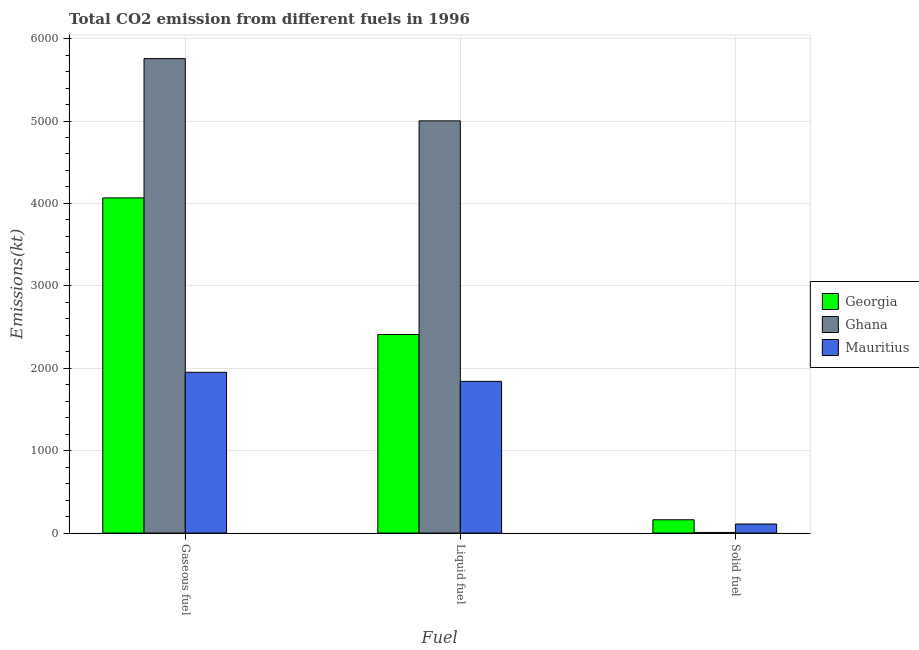How many groups of bars are there?
Give a very brief answer. 3. How many bars are there on the 3rd tick from the left?
Keep it short and to the point. 3. What is the label of the 3rd group of bars from the left?
Give a very brief answer. Solid fuel. What is the amount of co2 emissions from gaseous fuel in Mauritius?
Offer a terse response. 1950.84. Across all countries, what is the maximum amount of co2 emissions from solid fuel?
Offer a terse response. 161.35. Across all countries, what is the minimum amount of co2 emissions from solid fuel?
Give a very brief answer. 7.33. In which country was the amount of co2 emissions from gaseous fuel maximum?
Make the answer very short. Ghana. In which country was the amount of co2 emissions from liquid fuel minimum?
Give a very brief answer. Mauritius. What is the total amount of co2 emissions from gaseous fuel in the graph?
Ensure brevity in your answer.  1.18e+04. What is the difference between the amount of co2 emissions from liquid fuel in Georgia and that in Ghana?
Keep it short and to the point. -2592.57. What is the difference between the amount of co2 emissions from solid fuel in Georgia and the amount of co2 emissions from gaseous fuel in Mauritius?
Provide a succinct answer. -1789.5. What is the average amount of co2 emissions from liquid fuel per country?
Make the answer very short. 3083.95. What is the difference between the amount of co2 emissions from gaseous fuel and amount of co2 emissions from liquid fuel in Ghana?
Make the answer very short. 755.4. In how many countries, is the amount of co2 emissions from liquid fuel greater than 3800 kt?
Ensure brevity in your answer.  1. What is the ratio of the amount of co2 emissions from gaseous fuel in Ghana to that in Georgia?
Provide a succinct answer. 1.42. Is the amount of co2 emissions from solid fuel in Ghana less than that in Mauritius?
Make the answer very short. Yes. What is the difference between the highest and the second highest amount of co2 emissions from gaseous fuel?
Your response must be concise. 1690.49. What is the difference between the highest and the lowest amount of co2 emissions from gaseous fuel?
Keep it short and to the point. 3806.35. Is the sum of the amount of co2 emissions from liquid fuel in Georgia and Mauritius greater than the maximum amount of co2 emissions from gaseous fuel across all countries?
Offer a terse response. No. What does the 1st bar from the left in Liquid fuel represents?
Give a very brief answer. Georgia. What does the 3rd bar from the right in Liquid fuel represents?
Provide a succinct answer. Georgia. How many countries are there in the graph?
Keep it short and to the point. 3. Does the graph contain any zero values?
Provide a succinct answer. No. Does the graph contain grids?
Keep it short and to the point. Yes. How many legend labels are there?
Your response must be concise. 3. How are the legend labels stacked?
Your answer should be very brief. Vertical. What is the title of the graph?
Offer a very short reply. Total CO2 emission from different fuels in 1996. What is the label or title of the X-axis?
Provide a short and direct response. Fuel. What is the label or title of the Y-axis?
Provide a succinct answer. Emissions(kt). What is the Emissions(kt) in Georgia in Gaseous fuel?
Ensure brevity in your answer.  4066.7. What is the Emissions(kt) in Ghana in Gaseous fuel?
Your answer should be compact. 5757.19. What is the Emissions(kt) of Mauritius in Gaseous fuel?
Offer a terse response. 1950.84. What is the Emissions(kt) of Georgia in Liquid fuel?
Offer a very short reply. 2409.22. What is the Emissions(kt) of Ghana in Liquid fuel?
Ensure brevity in your answer.  5001.79. What is the Emissions(kt) of Mauritius in Liquid fuel?
Provide a short and direct response. 1840.83. What is the Emissions(kt) in Georgia in Solid fuel?
Offer a terse response. 161.35. What is the Emissions(kt) in Ghana in Solid fuel?
Your answer should be compact. 7.33. What is the Emissions(kt) in Mauritius in Solid fuel?
Ensure brevity in your answer.  110.01. Across all Fuel, what is the maximum Emissions(kt) of Georgia?
Your answer should be compact. 4066.7. Across all Fuel, what is the maximum Emissions(kt) in Ghana?
Make the answer very short. 5757.19. Across all Fuel, what is the maximum Emissions(kt) of Mauritius?
Offer a very short reply. 1950.84. Across all Fuel, what is the minimum Emissions(kt) in Georgia?
Offer a very short reply. 161.35. Across all Fuel, what is the minimum Emissions(kt) in Ghana?
Provide a short and direct response. 7.33. Across all Fuel, what is the minimum Emissions(kt) of Mauritius?
Make the answer very short. 110.01. What is the total Emissions(kt) of Georgia in the graph?
Offer a very short reply. 6637.27. What is the total Emissions(kt) of Ghana in the graph?
Give a very brief answer. 1.08e+04. What is the total Emissions(kt) in Mauritius in the graph?
Ensure brevity in your answer.  3901.69. What is the difference between the Emissions(kt) of Georgia in Gaseous fuel and that in Liquid fuel?
Your response must be concise. 1657.48. What is the difference between the Emissions(kt) in Ghana in Gaseous fuel and that in Liquid fuel?
Keep it short and to the point. 755.4. What is the difference between the Emissions(kt) in Mauritius in Gaseous fuel and that in Liquid fuel?
Your answer should be compact. 110.01. What is the difference between the Emissions(kt) in Georgia in Gaseous fuel and that in Solid fuel?
Provide a succinct answer. 3905.36. What is the difference between the Emissions(kt) in Ghana in Gaseous fuel and that in Solid fuel?
Keep it short and to the point. 5749.86. What is the difference between the Emissions(kt) of Mauritius in Gaseous fuel and that in Solid fuel?
Provide a short and direct response. 1840.83. What is the difference between the Emissions(kt) in Georgia in Liquid fuel and that in Solid fuel?
Give a very brief answer. 2247.87. What is the difference between the Emissions(kt) in Ghana in Liquid fuel and that in Solid fuel?
Keep it short and to the point. 4994.45. What is the difference between the Emissions(kt) of Mauritius in Liquid fuel and that in Solid fuel?
Your answer should be compact. 1730.82. What is the difference between the Emissions(kt) of Georgia in Gaseous fuel and the Emissions(kt) of Ghana in Liquid fuel?
Provide a succinct answer. -935.09. What is the difference between the Emissions(kt) in Georgia in Gaseous fuel and the Emissions(kt) in Mauritius in Liquid fuel?
Keep it short and to the point. 2225.87. What is the difference between the Emissions(kt) in Ghana in Gaseous fuel and the Emissions(kt) in Mauritius in Liquid fuel?
Your answer should be compact. 3916.36. What is the difference between the Emissions(kt) in Georgia in Gaseous fuel and the Emissions(kt) in Ghana in Solid fuel?
Ensure brevity in your answer.  4059.37. What is the difference between the Emissions(kt) in Georgia in Gaseous fuel and the Emissions(kt) in Mauritius in Solid fuel?
Your answer should be compact. 3956.69. What is the difference between the Emissions(kt) of Ghana in Gaseous fuel and the Emissions(kt) of Mauritius in Solid fuel?
Keep it short and to the point. 5647.18. What is the difference between the Emissions(kt) of Georgia in Liquid fuel and the Emissions(kt) of Ghana in Solid fuel?
Give a very brief answer. 2401.89. What is the difference between the Emissions(kt) of Georgia in Liquid fuel and the Emissions(kt) of Mauritius in Solid fuel?
Provide a short and direct response. 2299.21. What is the difference between the Emissions(kt) in Ghana in Liquid fuel and the Emissions(kt) in Mauritius in Solid fuel?
Your response must be concise. 4891.78. What is the average Emissions(kt) in Georgia per Fuel?
Offer a very short reply. 2212.42. What is the average Emissions(kt) in Ghana per Fuel?
Provide a short and direct response. 3588.77. What is the average Emissions(kt) in Mauritius per Fuel?
Offer a very short reply. 1300.56. What is the difference between the Emissions(kt) of Georgia and Emissions(kt) of Ghana in Gaseous fuel?
Offer a terse response. -1690.49. What is the difference between the Emissions(kt) in Georgia and Emissions(kt) in Mauritius in Gaseous fuel?
Keep it short and to the point. 2115.86. What is the difference between the Emissions(kt) of Ghana and Emissions(kt) of Mauritius in Gaseous fuel?
Give a very brief answer. 3806.35. What is the difference between the Emissions(kt) in Georgia and Emissions(kt) in Ghana in Liquid fuel?
Your answer should be compact. -2592.57. What is the difference between the Emissions(kt) of Georgia and Emissions(kt) of Mauritius in Liquid fuel?
Keep it short and to the point. 568.38. What is the difference between the Emissions(kt) in Ghana and Emissions(kt) in Mauritius in Liquid fuel?
Keep it short and to the point. 3160.95. What is the difference between the Emissions(kt) in Georgia and Emissions(kt) in Ghana in Solid fuel?
Ensure brevity in your answer.  154.01. What is the difference between the Emissions(kt) in Georgia and Emissions(kt) in Mauritius in Solid fuel?
Your response must be concise. 51.34. What is the difference between the Emissions(kt) in Ghana and Emissions(kt) in Mauritius in Solid fuel?
Provide a short and direct response. -102.68. What is the ratio of the Emissions(kt) in Georgia in Gaseous fuel to that in Liquid fuel?
Your response must be concise. 1.69. What is the ratio of the Emissions(kt) of Ghana in Gaseous fuel to that in Liquid fuel?
Make the answer very short. 1.15. What is the ratio of the Emissions(kt) in Mauritius in Gaseous fuel to that in Liquid fuel?
Ensure brevity in your answer.  1.06. What is the ratio of the Emissions(kt) in Georgia in Gaseous fuel to that in Solid fuel?
Your answer should be very brief. 25.2. What is the ratio of the Emissions(kt) of Ghana in Gaseous fuel to that in Solid fuel?
Keep it short and to the point. 785. What is the ratio of the Emissions(kt) in Mauritius in Gaseous fuel to that in Solid fuel?
Your response must be concise. 17.73. What is the ratio of the Emissions(kt) of Georgia in Liquid fuel to that in Solid fuel?
Offer a terse response. 14.93. What is the ratio of the Emissions(kt) of Ghana in Liquid fuel to that in Solid fuel?
Your answer should be very brief. 682. What is the ratio of the Emissions(kt) of Mauritius in Liquid fuel to that in Solid fuel?
Provide a short and direct response. 16.73. What is the difference between the highest and the second highest Emissions(kt) in Georgia?
Ensure brevity in your answer.  1657.48. What is the difference between the highest and the second highest Emissions(kt) of Ghana?
Ensure brevity in your answer.  755.4. What is the difference between the highest and the second highest Emissions(kt) of Mauritius?
Your answer should be very brief. 110.01. What is the difference between the highest and the lowest Emissions(kt) of Georgia?
Keep it short and to the point. 3905.36. What is the difference between the highest and the lowest Emissions(kt) in Ghana?
Your answer should be very brief. 5749.86. What is the difference between the highest and the lowest Emissions(kt) in Mauritius?
Offer a terse response. 1840.83. 